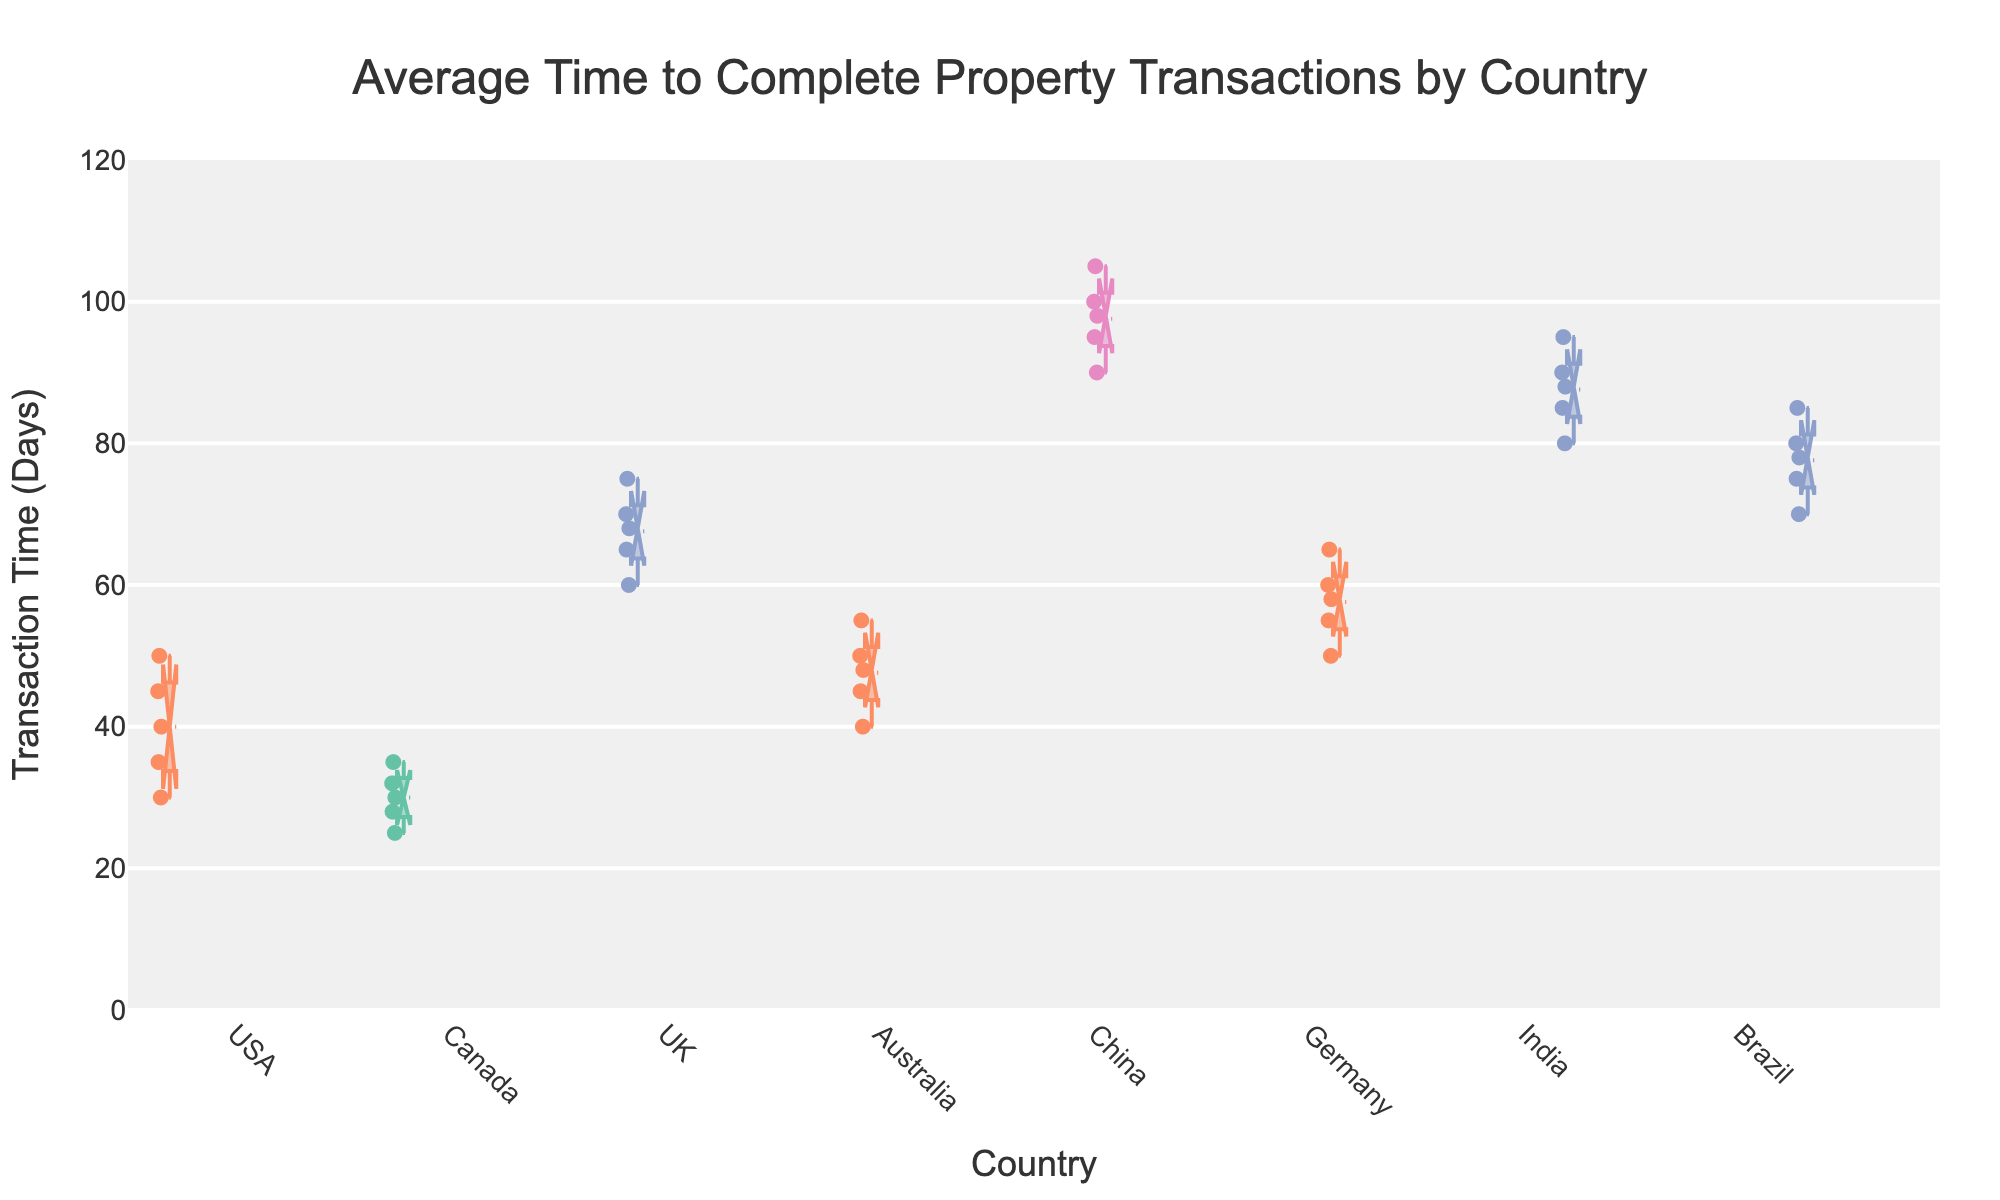What is the title of the plot? The title of the plot is mentioned at the top of the figure, indicating the subject of the data being visualized.
Answer: Average Time to Complete Property Transactions by Country What does the y-axis represent? The y-axis represents the transaction time in days. This can be inferred from the label next to the y-axis.
Answer: Transaction Time (Days) Which country has the lowest average transaction time? By looking at the medians (lines inside the boxes), the box corresponding to Canada appears the lowest on the y-axis.
Answer: Canada How does Germany's average transaction time compare to Australia's? To compare the average transaction times, refer to the medians inside the boxes for both countries. Germany's median appears slightly higher than Australia's.
Answer: Germany's average is higher Are China's transaction times more variable than the UK's? To determine variability, compare the box lengths and the whisker lengths of China and the UK. China's box and whiskers are longer, indicating more variability.
Answer: Yes, China's transaction times are more variable Which countries are categorized as 'Moderate' in terms of legal requirements? The countries can be identified by the color corresponding to 'Moderate' in the legend. The 'Moderate' category color is consistent across multiple boxes.
Answer: USA, Australia, Germany What is the median transaction time for Brazil? The median is the line inside the box for Brazil. You can find the approximate value by locating this line on the y-axis.
Answer: Approximately 75 days Is there any country with a notch not overlapping with those of other countries? Check if any notch (indentation) in the middle of the boxes stands alone without overlapping with any other country's notch, indicating a significant difference.
Answer: Yes, China's notch does not overlap with others Which country has the highest average transaction time? What's the value? The box with the highest median line indicates the country. China has the highest average transaction time.
Answer: China, approximately 98 days Which legal category generally takes the longest to complete transactions? Look for the color in the legend corresponding to the 'Very Strict' category and see which country it relates to, then compare transaction times.
Answer: Very Strict 